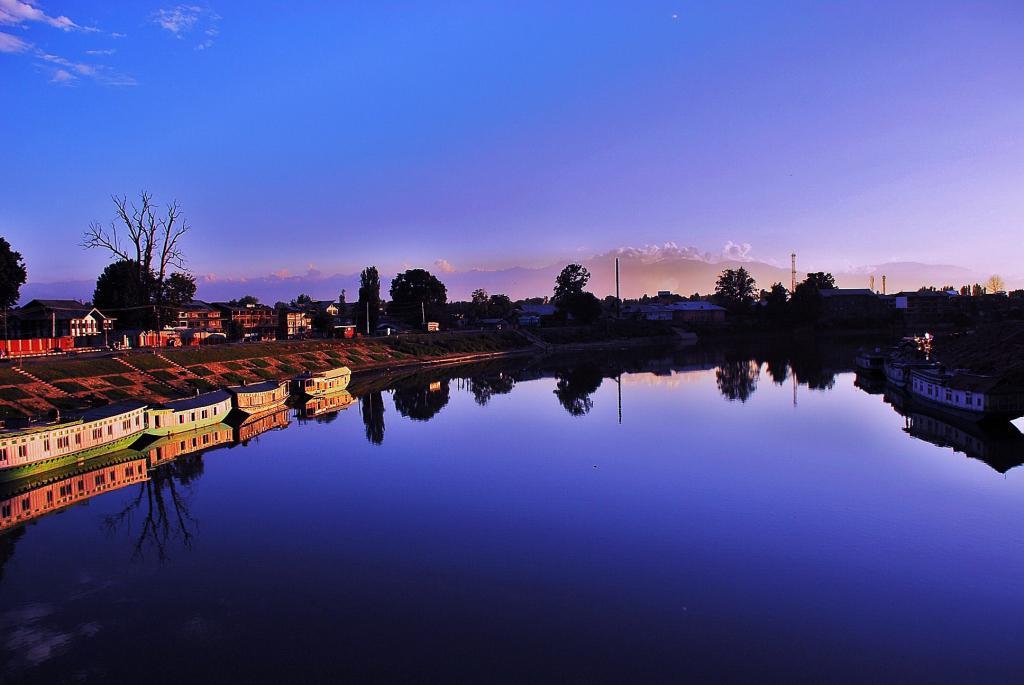How would you summarize this image in a sentence or two? In this picture I can see boats on the water, there are buildings, trees, there are mountains, and in the background there is the sky. 